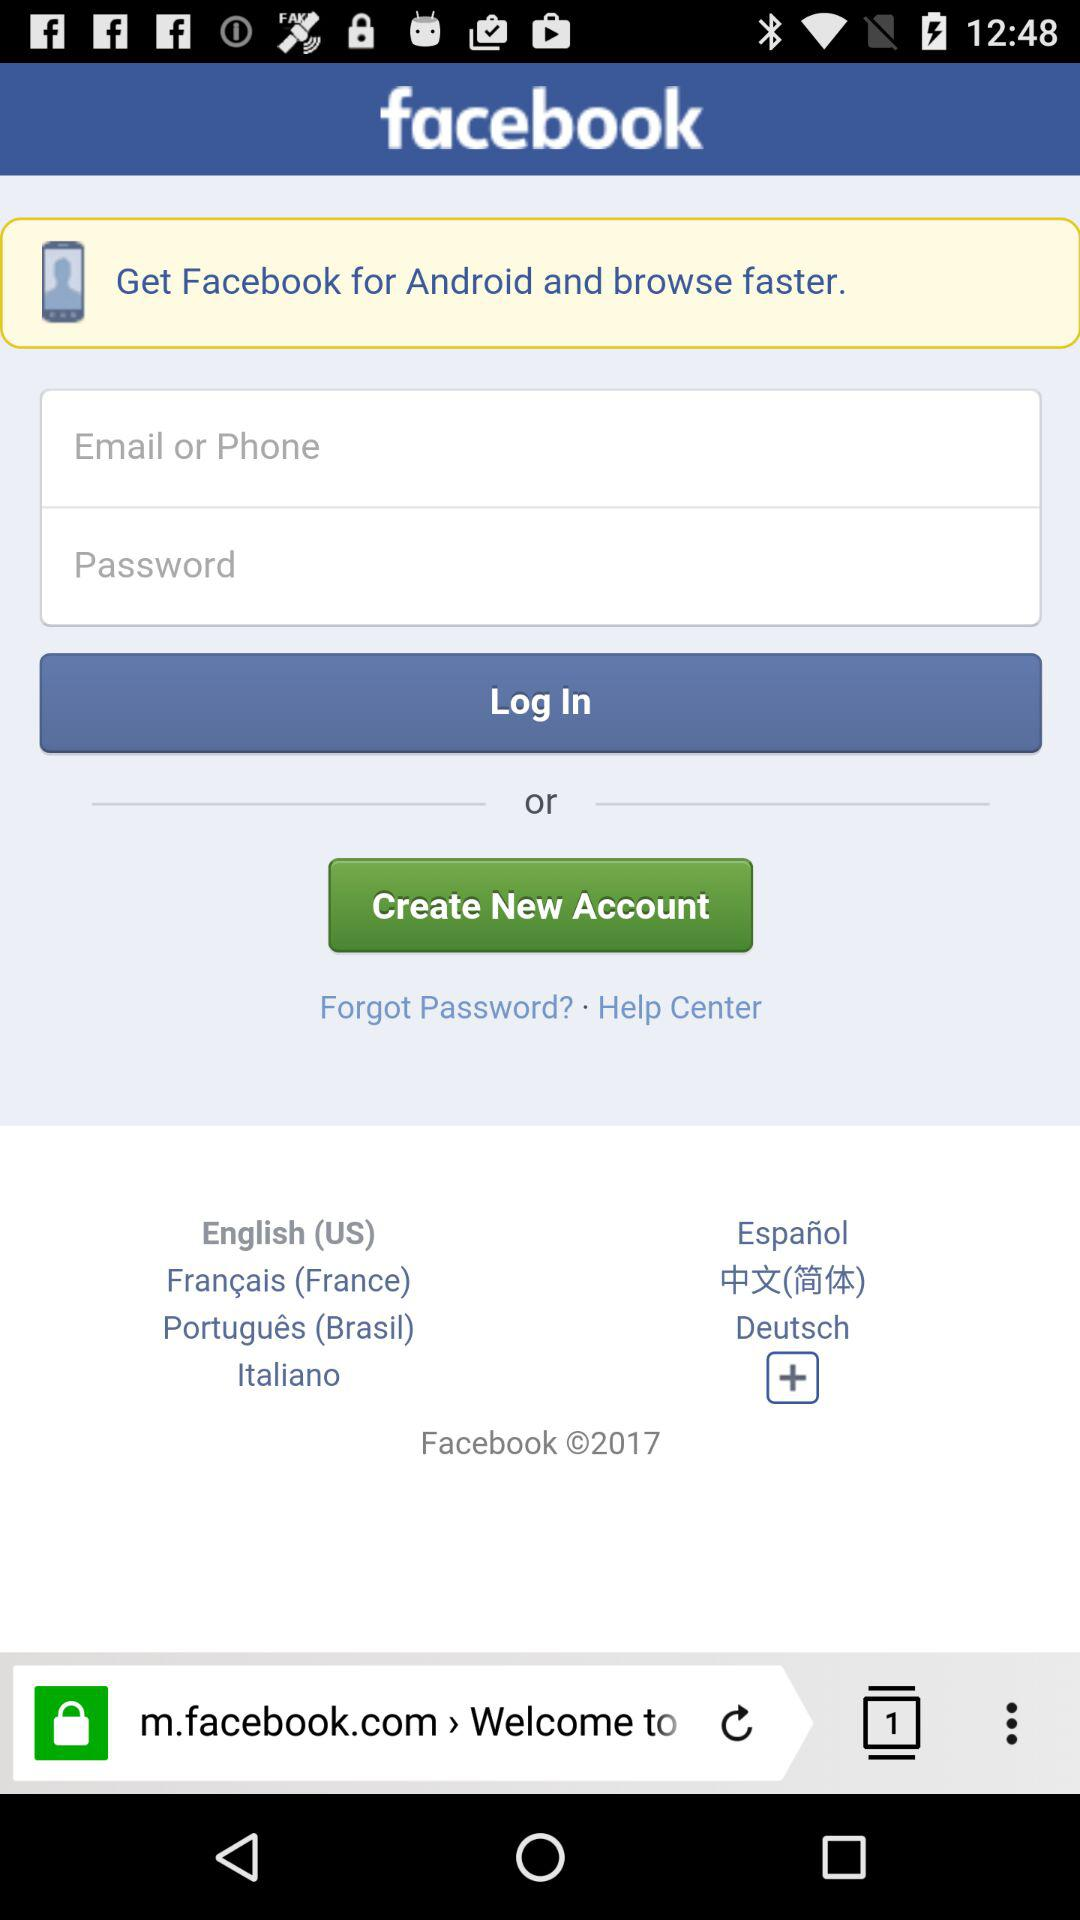What is the copyright year? The copyright year is 2017. 